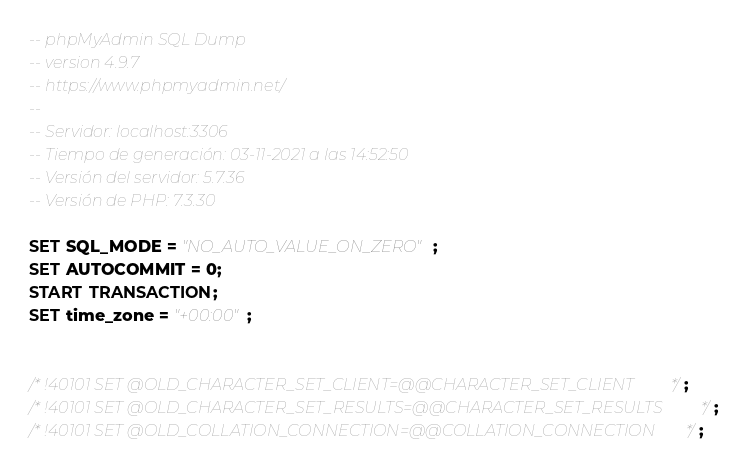<code> <loc_0><loc_0><loc_500><loc_500><_SQL_>-- phpMyAdmin SQL Dump
-- version 4.9.7
-- https://www.phpmyadmin.net/
--
-- Servidor: localhost:3306
-- Tiempo de generación: 03-11-2021 a las 14:52:50
-- Versión del servidor: 5.7.36
-- Versión de PHP: 7.3.30

SET SQL_MODE = "NO_AUTO_VALUE_ON_ZERO";
SET AUTOCOMMIT = 0;
START TRANSACTION;
SET time_zone = "+00:00";


/*!40101 SET @OLD_CHARACTER_SET_CLIENT=@@CHARACTER_SET_CLIENT */;
/*!40101 SET @OLD_CHARACTER_SET_RESULTS=@@CHARACTER_SET_RESULTS */;
/*!40101 SET @OLD_COLLATION_CONNECTION=@@COLLATION_CONNECTION */;</code> 